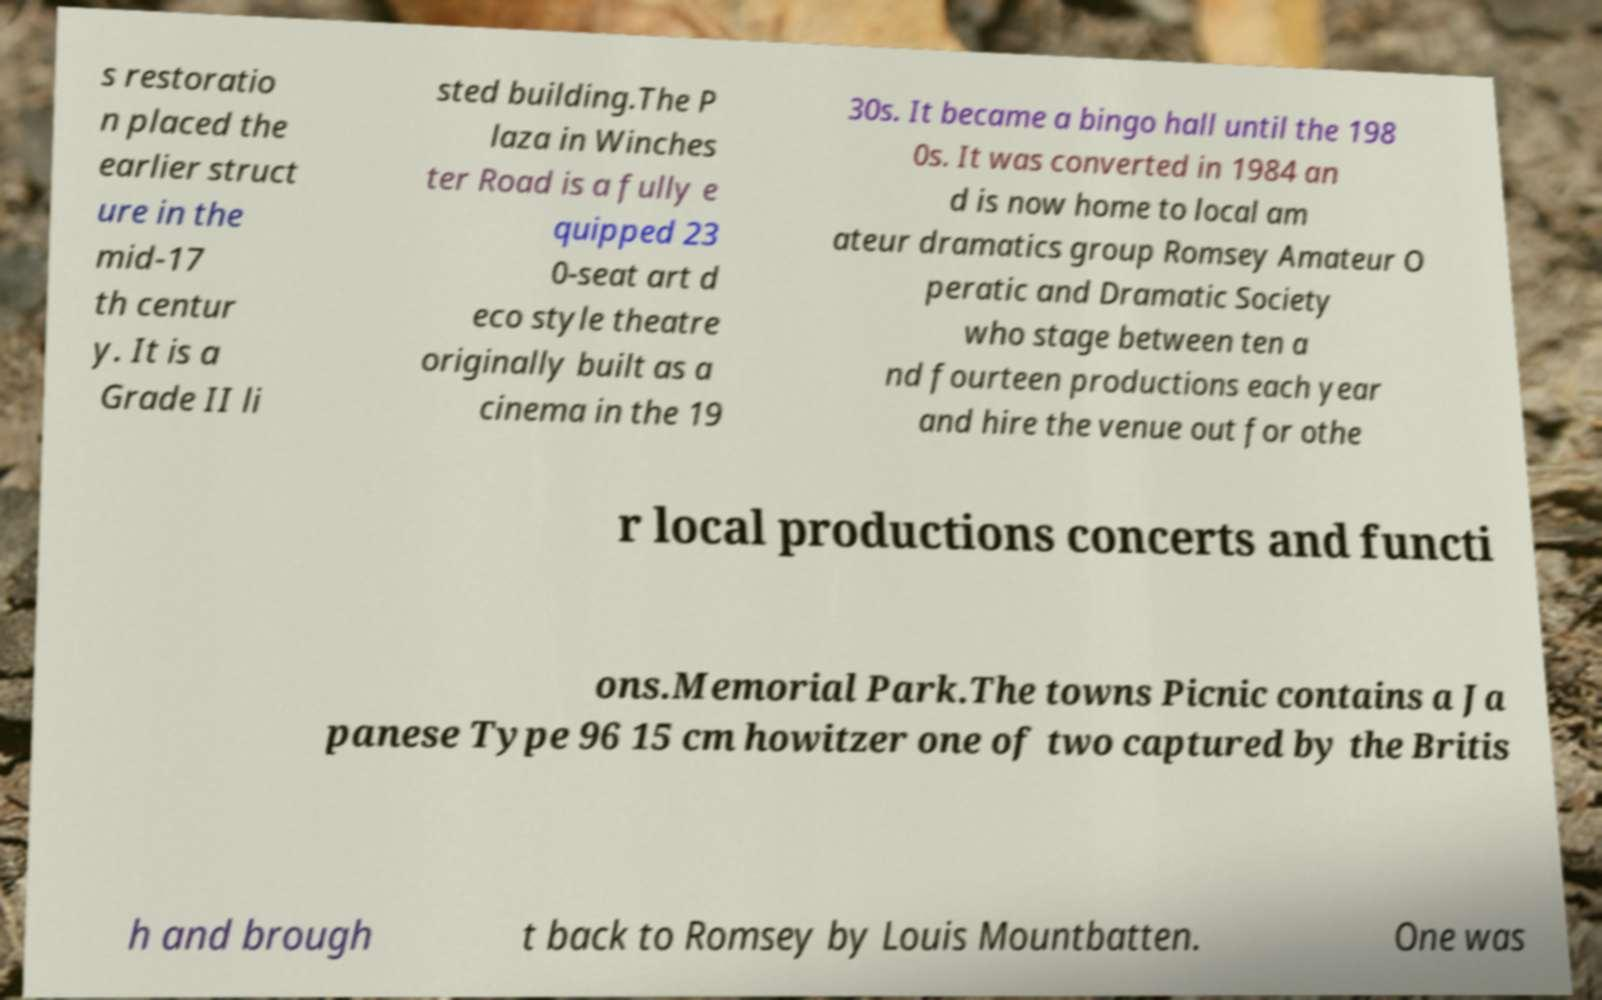I need the written content from this picture converted into text. Can you do that? s restoratio n placed the earlier struct ure in the mid-17 th centur y. It is a Grade II li sted building.The P laza in Winches ter Road is a fully e quipped 23 0-seat art d eco style theatre originally built as a cinema in the 19 30s. It became a bingo hall until the 198 0s. It was converted in 1984 an d is now home to local am ateur dramatics group Romsey Amateur O peratic and Dramatic Society who stage between ten a nd fourteen productions each year and hire the venue out for othe r local productions concerts and functi ons.Memorial Park.The towns Picnic contains a Ja panese Type 96 15 cm howitzer one of two captured by the Britis h and brough t back to Romsey by Louis Mountbatten. One was 